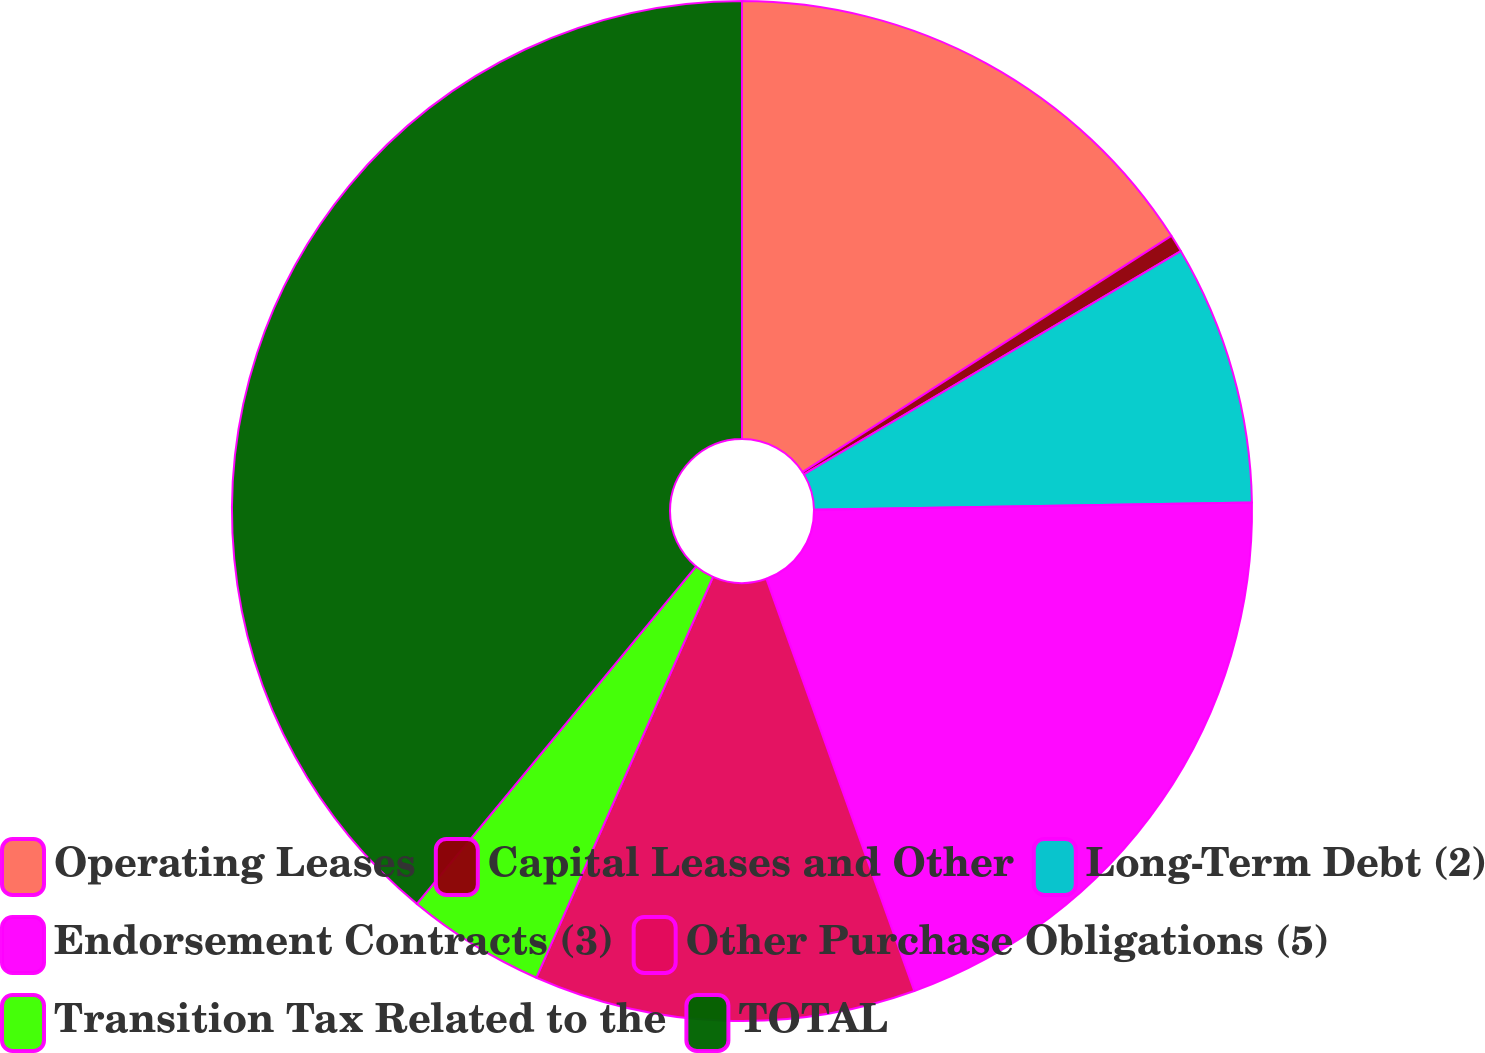Convert chart to OTSL. <chart><loc_0><loc_0><loc_500><loc_500><pie_chart><fcel>Operating Leases<fcel>Capital Leases and Other<fcel>Long-Term Debt (2)<fcel>Endorsement Contracts (3)<fcel>Other Purchase Obligations (5)<fcel>Transition Tax Related to the<fcel>TOTAL<nl><fcel>15.93%<fcel>0.56%<fcel>8.25%<fcel>19.78%<fcel>12.09%<fcel>4.4%<fcel>39.0%<nl></chart> 